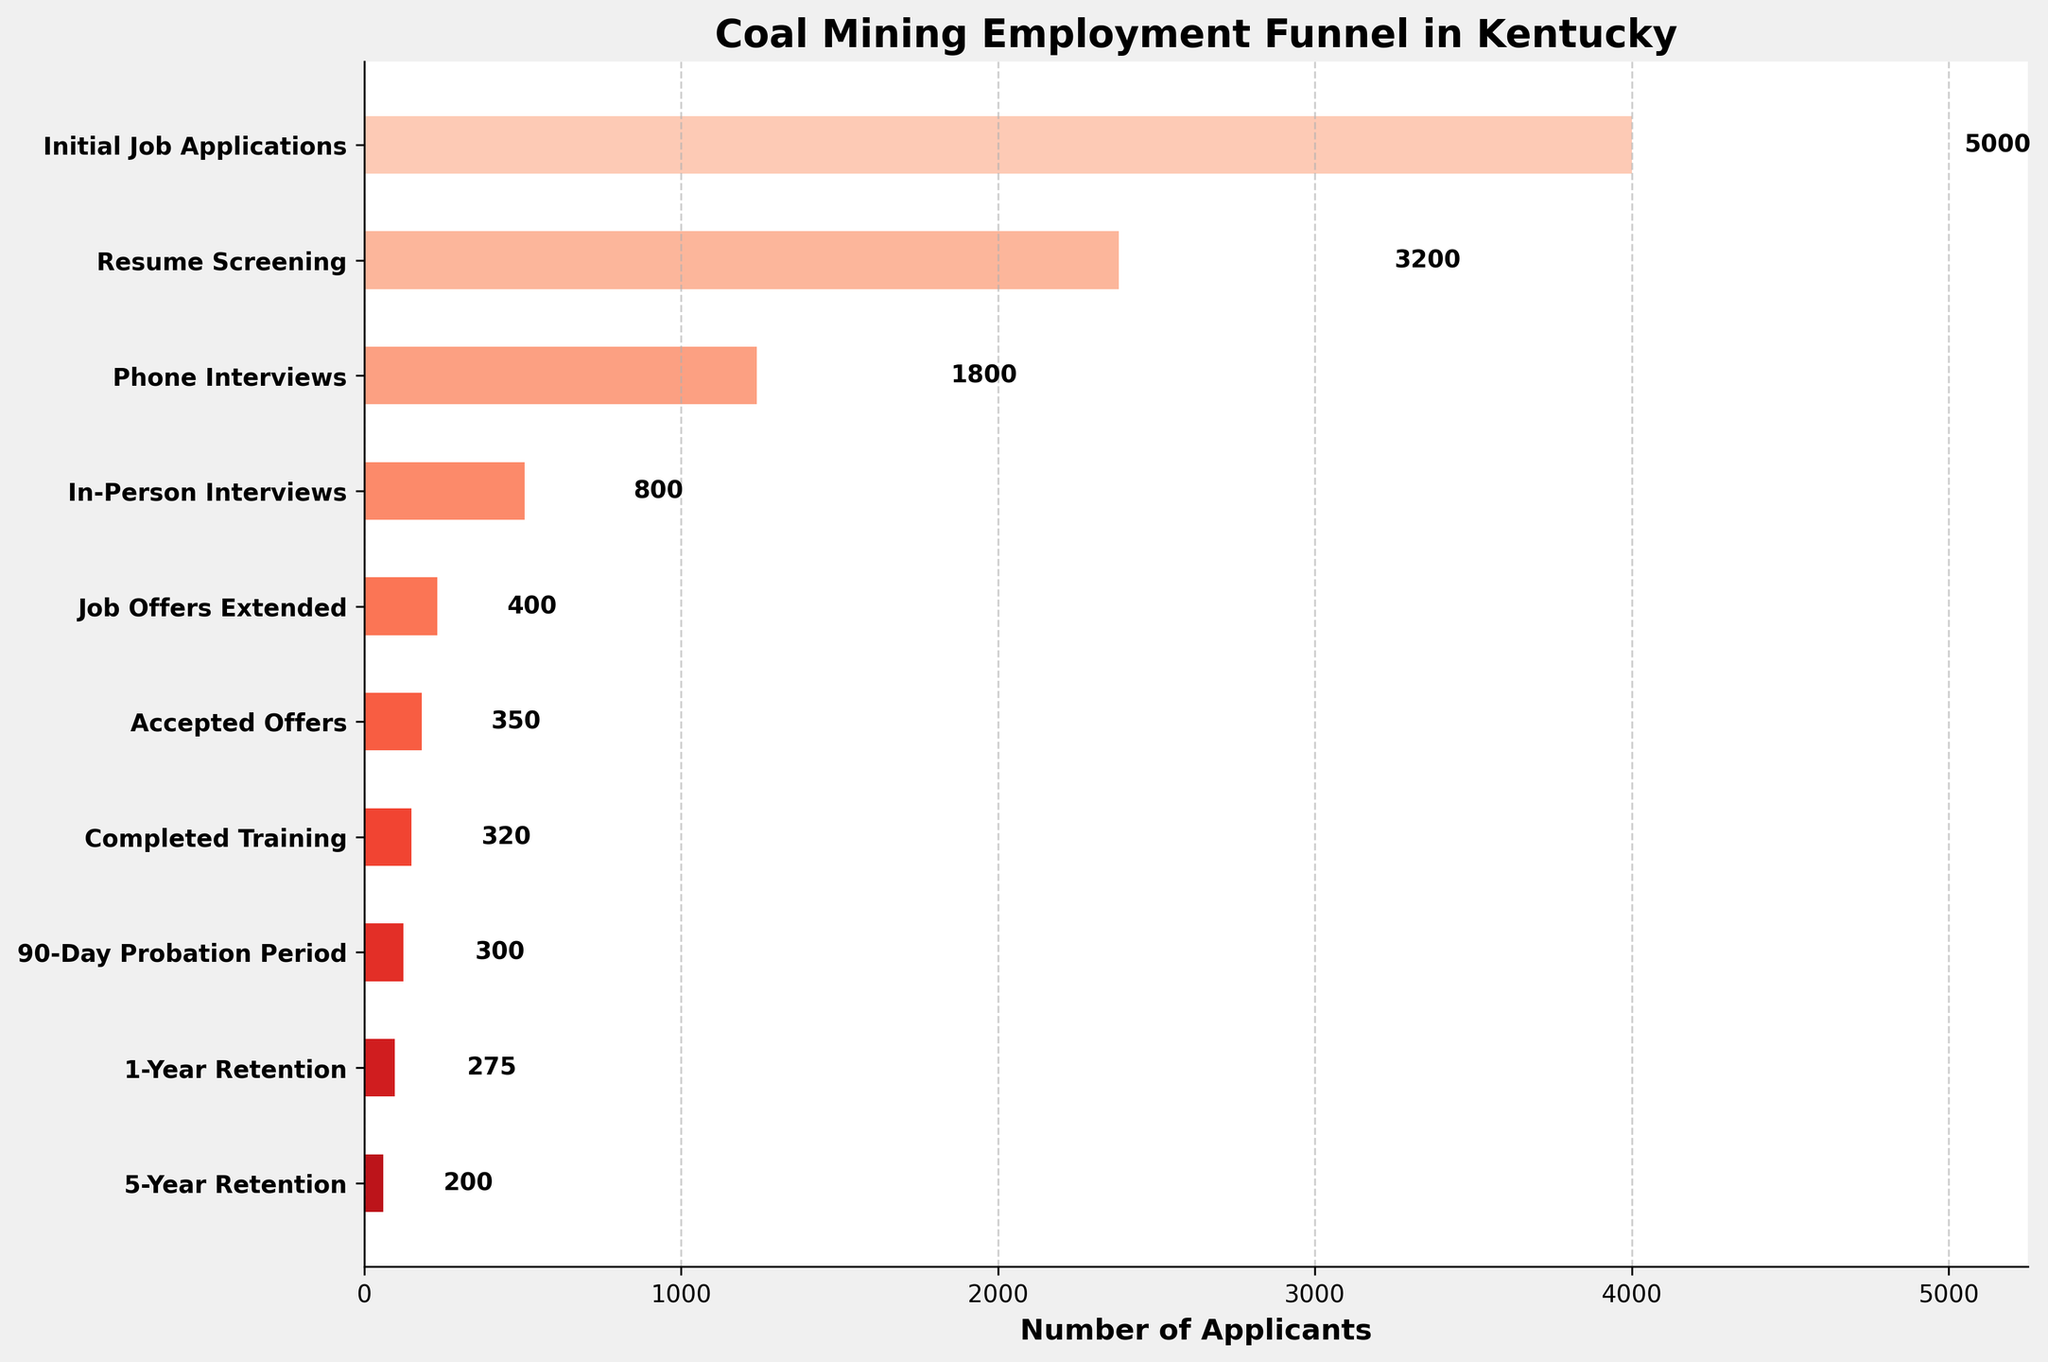What is the title of the funnel chart? The title is located at the top of the funnel chart in larger, bold text. It is meant to describe what the chart is about.
Answer: Coal Mining Employment Funnel in Kentucky How many stages are shown in the funnel chart? By observing the y-axis with the stage names, one can count the total number of stages listed in the funnel chart.
Answer: 10 Which stage has the highest number of applicants? The funnel chart bars represent the number of applicants at each stage. The stage with the longest bar will have the highest number of applicants.
Answer: Initial Job Applications What is the number of applicants at the Resume Screening stage? One can locate the Resume Screening stage on the y-axis and follow the bar to see the number of applicants next to it.
Answer: 3200 How many applicants accepted job offers? Find the 'Accepted Offers' stage on the y-axis and note the value listed next to it.
Answer: 350 What is the difference in the number of applicants between the Initial Job Applications and the 5-Year Retention stages? Identify the values for both stages and subtract the smaller value (5-Year Retention) from the larger value (Initial Job Applications).
Answer: 5000 - 200 = 4800 How many applicants completed the training out of those who accepted job offers? Locate the 'Accepted Offers' and 'Completed Training' stages. Subtract the number of applicants who completed training from those who accepted job offers.
Answer: 350 - 320 = 30 What percentage of applicants who passed the 90-Day Probation Period were retained for 1 year? Locate the values for the stages '90-Day Probation Period' and '1-Year Retention', then use the formula (1-Year Retention / 90-Day Probation Period) * 100 to find the percentage.
Answer: (275 / 300) * 100 ≈ 91.67% Which stage has the steepest drop in the number of applicants? To find the steepest drop, one needs to identify the stages with the largest difference in values between consecutive stages by comparing the lengths of the bars.
Answer: In-Person Interviews to Job Offers Extended (800 - 400 = 400) What is the average number of applicants from the Initial Job Applications stage to the Phone Interviews stage? Calculate the average by adding the number of applicants for 'Initial Job Applications', 'Resume Screening', and 'Phone Interviews', then divide by the number of stages (3).
Answer: (5000 + 3200 + 1800) / 3 = 3333.33 